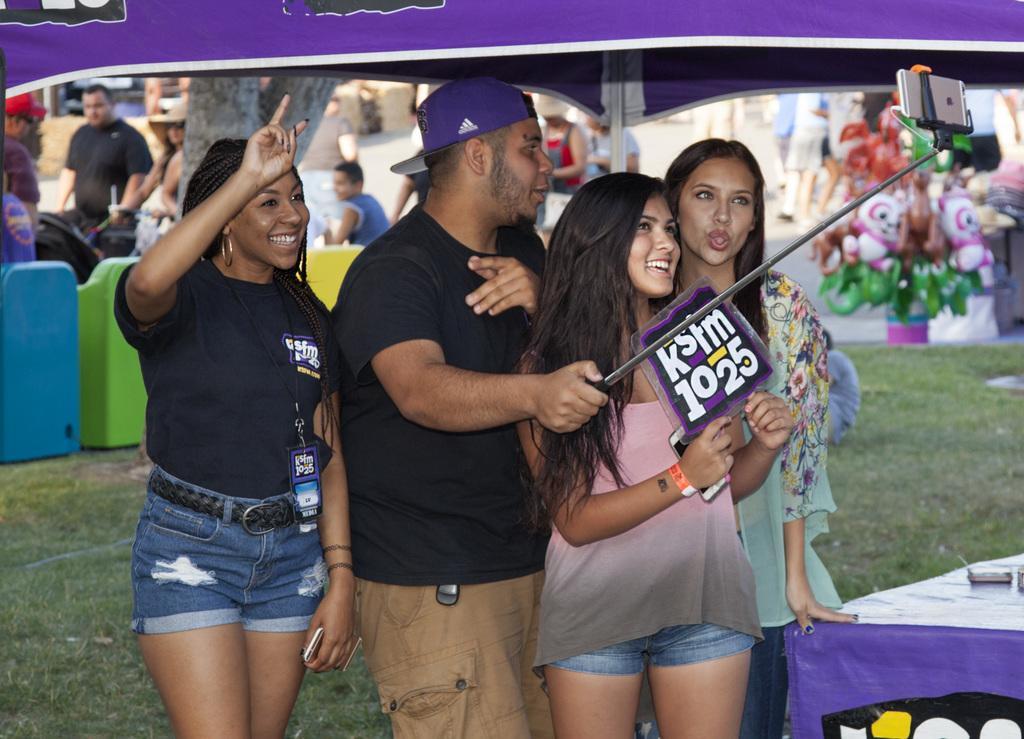Could you give a brief overview of what you see in this image? In the image we can see there are people standing on the ground and the ground is covered with grass. They are wearing id card in their neck, the woman is holding a poster in her hand and the man is holding a selfie stick and a phone is kept on the stand. Behind there are other people standing. 